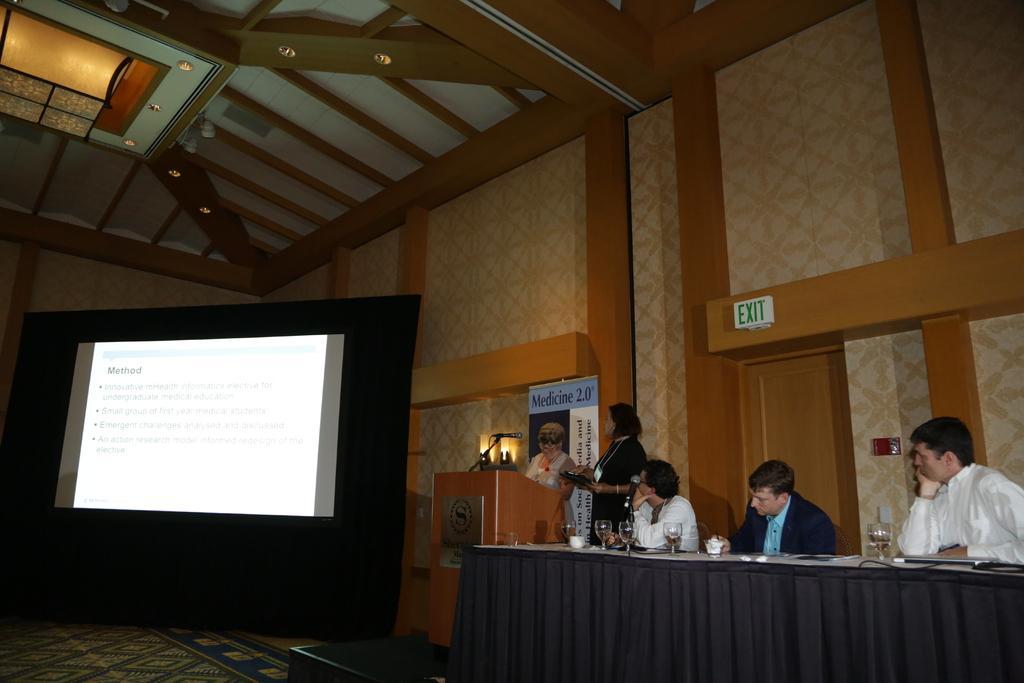Can you describe this image briefly? This is an inside view of a room. On the right side three men are sitting on the chairs in front of the table which is covered with a cloth. On the table there are few glasses. Beside two women are standing in front of the podium. On the left side there is a screen on which I can see some text. In the background there is a wall. 